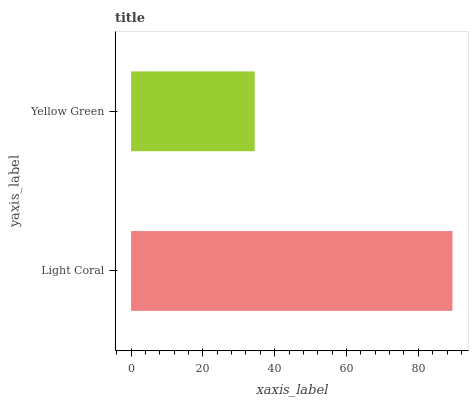Is Yellow Green the minimum?
Answer yes or no. Yes. Is Light Coral the maximum?
Answer yes or no. Yes. Is Yellow Green the maximum?
Answer yes or no. No. Is Light Coral greater than Yellow Green?
Answer yes or no. Yes. Is Yellow Green less than Light Coral?
Answer yes or no. Yes. Is Yellow Green greater than Light Coral?
Answer yes or no. No. Is Light Coral less than Yellow Green?
Answer yes or no. No. Is Light Coral the high median?
Answer yes or no. Yes. Is Yellow Green the low median?
Answer yes or no. Yes. Is Yellow Green the high median?
Answer yes or no. No. Is Light Coral the low median?
Answer yes or no. No. 